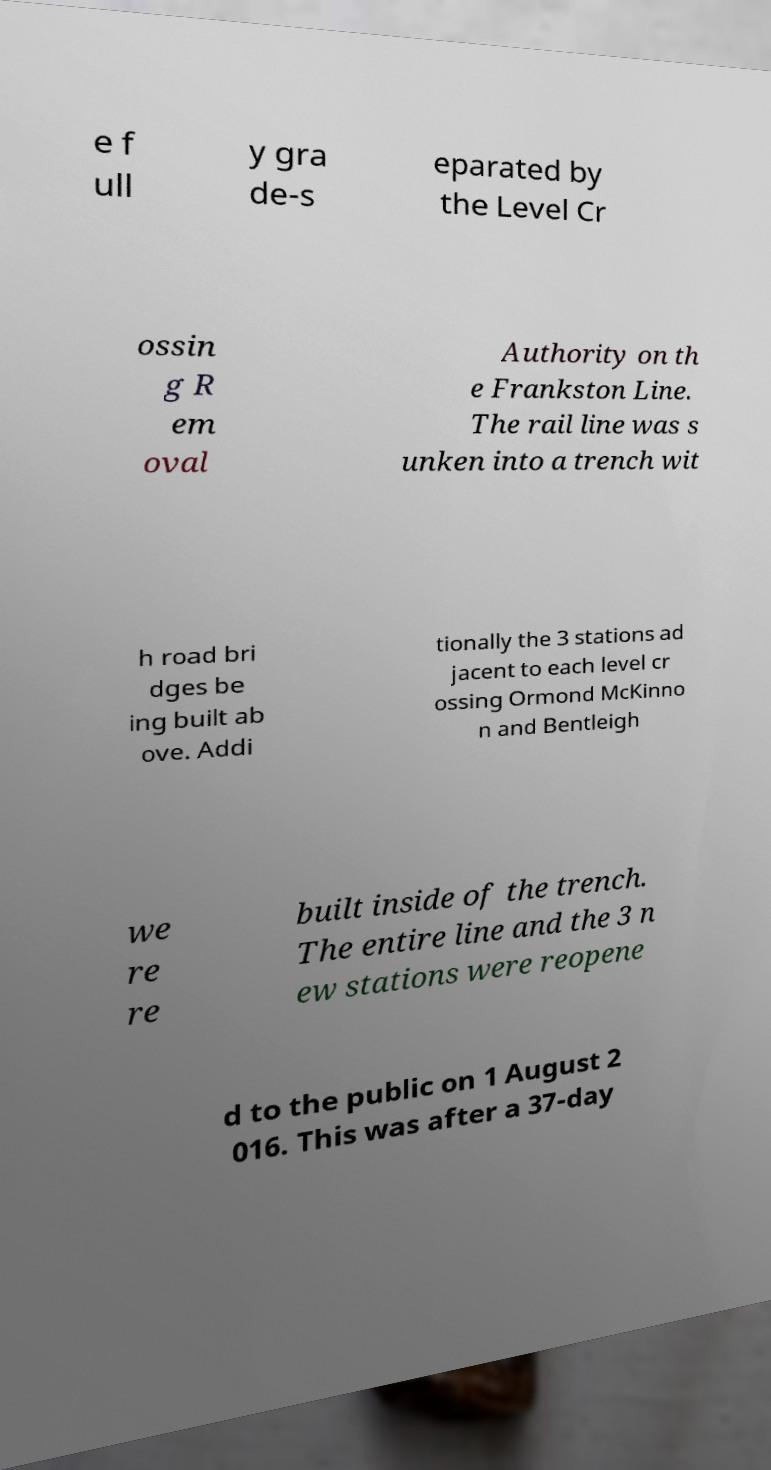What messages or text are displayed in this image? I need them in a readable, typed format. e f ull y gra de-s eparated by the Level Cr ossin g R em oval Authority on th e Frankston Line. The rail line was s unken into a trench wit h road bri dges be ing built ab ove. Addi tionally the 3 stations ad jacent to each level cr ossing Ormond McKinno n and Bentleigh we re re built inside of the trench. The entire line and the 3 n ew stations were reopene d to the public on 1 August 2 016. This was after a 37-day 